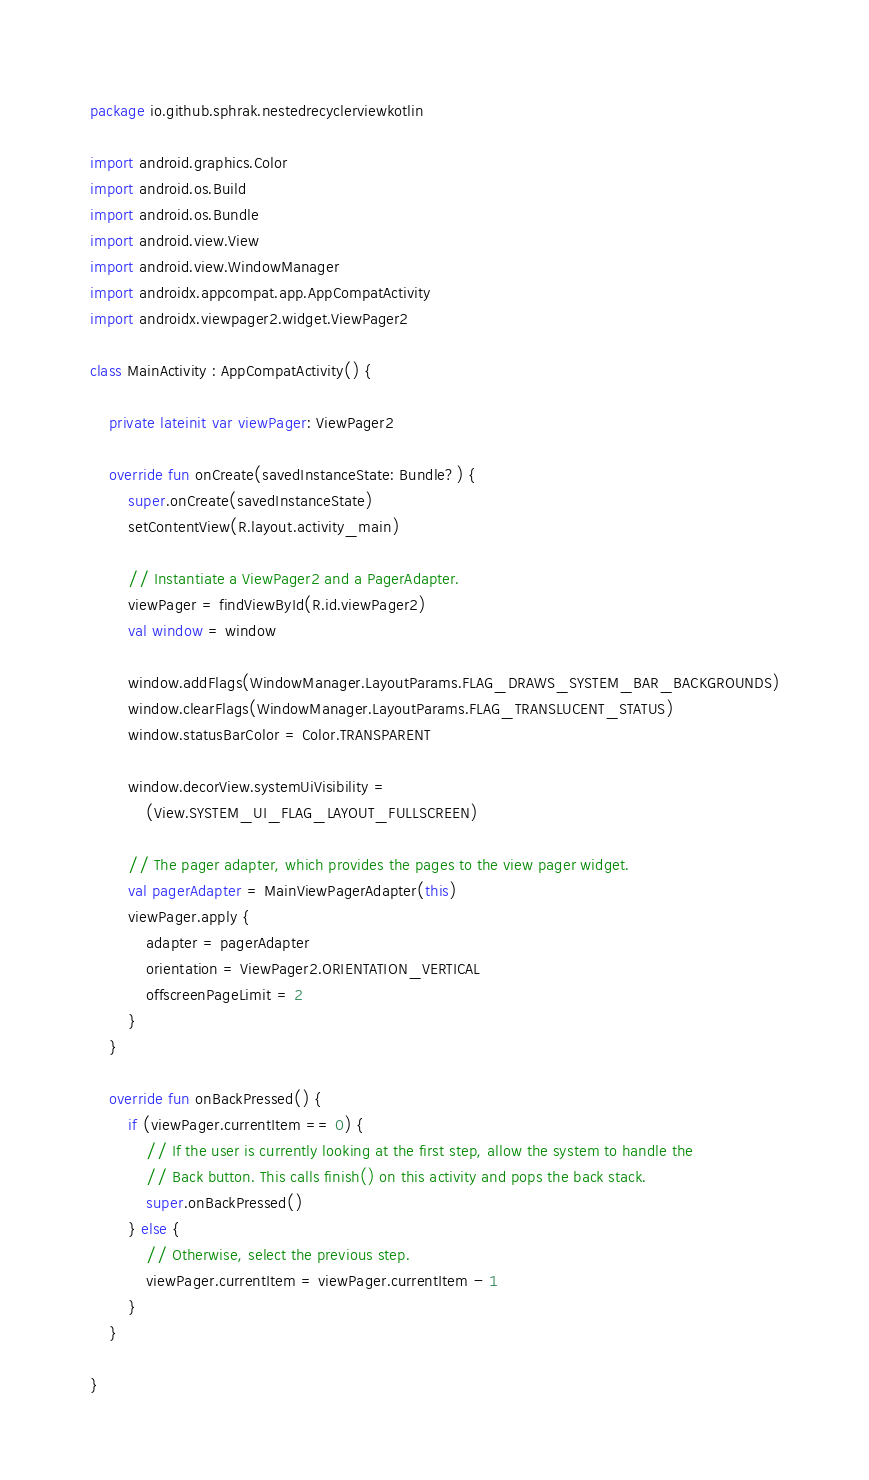<code> <loc_0><loc_0><loc_500><loc_500><_Kotlin_>package io.github.sphrak.nestedrecyclerviewkotlin

import android.graphics.Color
import android.os.Build
import android.os.Bundle
import android.view.View
import android.view.WindowManager
import androidx.appcompat.app.AppCompatActivity
import androidx.viewpager2.widget.ViewPager2

class MainActivity : AppCompatActivity() {

    private lateinit var viewPager: ViewPager2

    override fun onCreate(savedInstanceState: Bundle?) {
        super.onCreate(savedInstanceState)
        setContentView(R.layout.activity_main)

        // Instantiate a ViewPager2 and a PagerAdapter.
        viewPager = findViewById(R.id.viewPager2)
        val window = window

        window.addFlags(WindowManager.LayoutParams.FLAG_DRAWS_SYSTEM_BAR_BACKGROUNDS)
        window.clearFlags(WindowManager.LayoutParams.FLAG_TRANSLUCENT_STATUS)
        window.statusBarColor = Color.TRANSPARENT

        window.decorView.systemUiVisibility =
            (View.SYSTEM_UI_FLAG_LAYOUT_FULLSCREEN)

        // The pager adapter, which provides the pages to the view pager widget.
        val pagerAdapter = MainViewPagerAdapter(this)
        viewPager.apply {
            adapter = pagerAdapter
            orientation = ViewPager2.ORIENTATION_VERTICAL
            offscreenPageLimit = 2
        }
    }

    override fun onBackPressed() {
        if (viewPager.currentItem == 0) {
            // If the user is currently looking at the first step, allow the system to handle the
            // Back button. This calls finish() on this activity and pops the back stack.
            super.onBackPressed()
        } else {
            // Otherwise, select the previous step.
            viewPager.currentItem = viewPager.currentItem - 1
        }
    }

}
</code> 